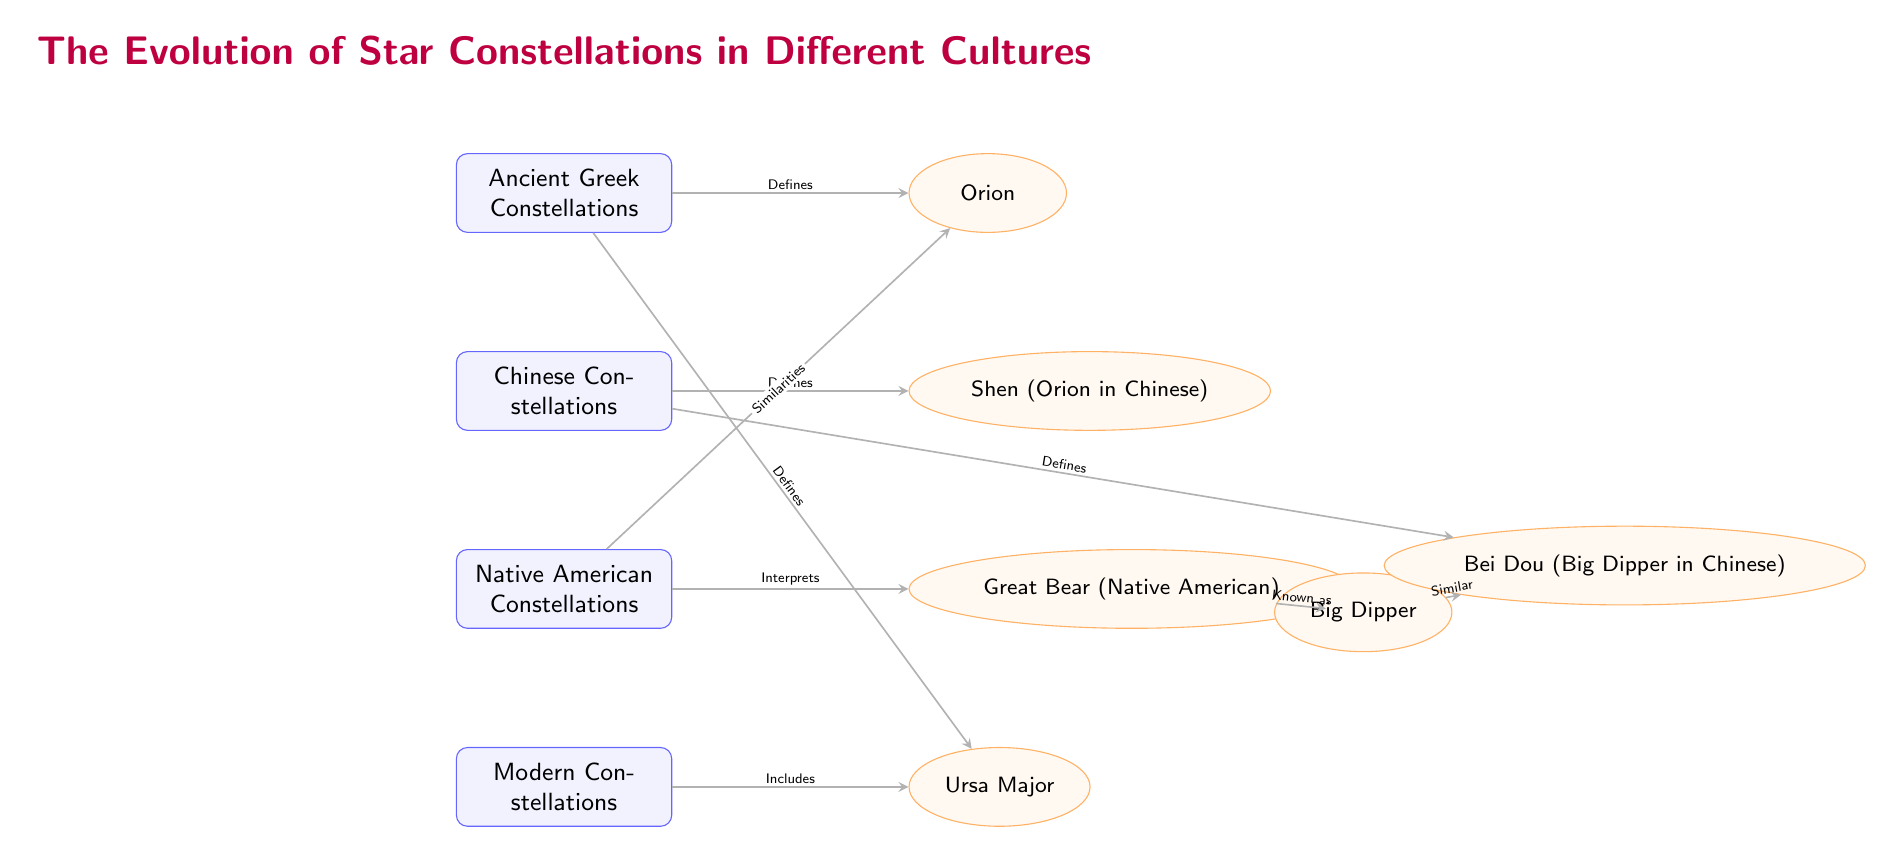What are the four cultures represented in the diagram? The diagram lists four cultures: Ancient Greek, Chinese, Native American, and Modern. Each culture appears as a rectangle node labeled with its name.
Answer: Ancient Greek, Chinese, Native American, Modern Which constellation is defined by the Ancient Greek culture? The diagram shows that the Ancient Greek culture has an arrow pointing to the Orion constellation, indicating that it defines this constellation.
Answer: Orion How many total constellations are represented in the diagram? By counting the ellipses representing the constellations, we find five distinct constellations: Orion, Shen, Great Bear, Ursa Major, and Big Dipper.
Answer: 5 What is the relationship between the Great Bear and Orion? The diagram indicates a similarity relationship between the Great Bear and Orion, as represented by a connecting arrow with the label "Similarities."
Answer: Similarities Which culture defines the Bei Dou constellation? The diagram shows a direct link from the Chinese culture node to the Bei Dou constellation node, indicating that it defines this constellation.
Answer: Chinese How do the Big Dipper and Bei Dou constellations relate? The diagram illustrates a "Similar" relationship, meaning both constellations have comparable characteristics or meanings, as indicated by the arrow connecting them.
Answer: Similar What defines the constellation identified as Ursa Major? The diagram outlines that both the Ancient Greek and Modern cultures have directed arrows indicating they define the Ursa Major constellation.
Answer: Ancient Greek, Modern Which constellation does the Native American culture interpret? According to the diagram, the Native American culture has an arrow corresponding to the Great Bear constellation, which indicates that this culture interprets it.
Answer: Great Bear How many edges connect the cultures to their respective constellations? By examining the arrows connecting cultures to constellations in the diagram, we count six distinct edges that connect cultures to constellations.
Answer: 6 